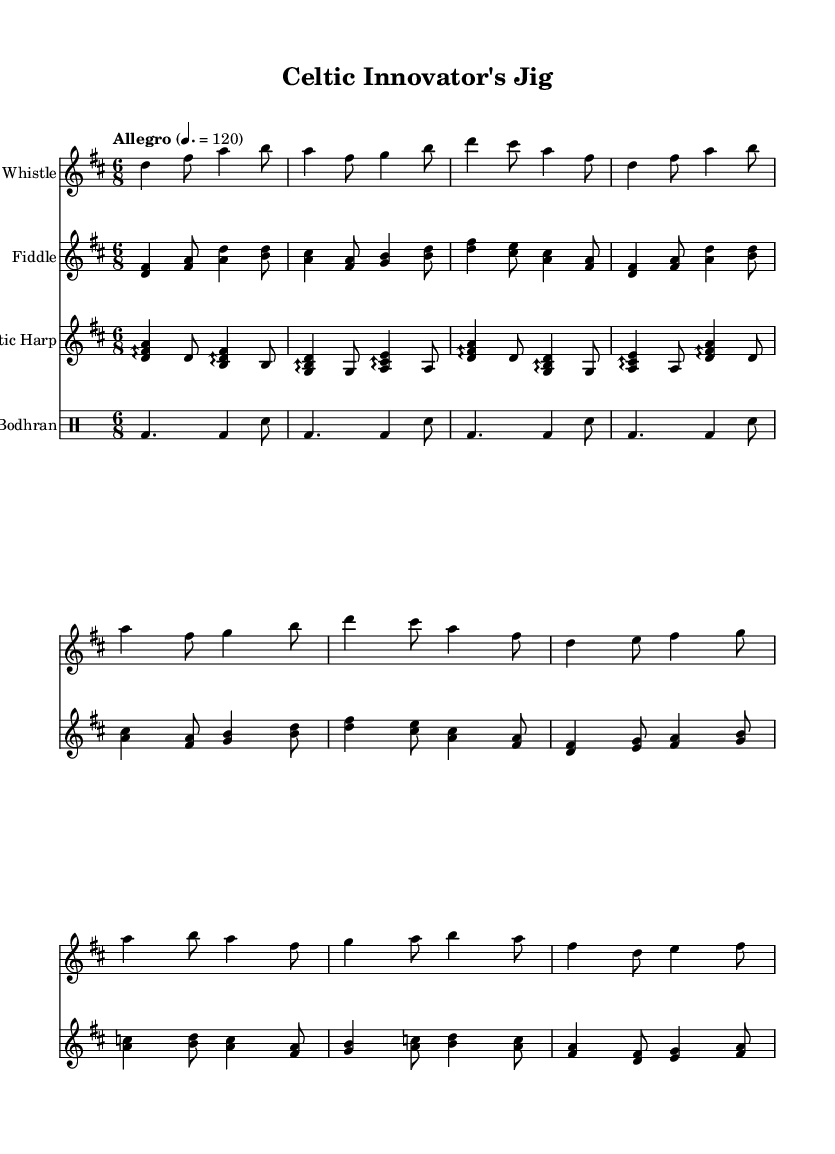What is the key signature of this music? The key signature is shown at the beginning of the staff, and it indicates D major. D major has two sharps: F# and C#.
Answer: D major What is the time signature of this music? The time signature appears right after the key signature and is indicated as 6/8. This means there are 6 eighth notes per measure.
Answer: 6/8 What is the tempo marking for this piece? The tempo marking is located near the top of the score and indicates how fast the piece should be played. It states "Allegro," and the number 120 indicates the beats per minute.
Answer: Allegro 120 How many instruments are used in this score? By looking at the score, each line indicates a different instrument. There are four distinct instruments: Tin Whistle, Fiddle, Celtic Harp, and Bodhran.
Answer: Four What type of musical form does this piece likely represent? The repeated melodic phrases often found in traditional folk music suggest a binary or repeated structure typically used in jigs. This can be observed in the stanza-like annotations of the music.
Answer: Jig What is the primary rhythmic feel of this piece? The piece is set in 6/8 time with a lively tempo, resulting in a flowing and dance-like feel, which is characteristic of many Celtic folk styles. This rhythmic arrangement emphasizes a triplet feel.
Answer: Lively What does the arpeggio notation indicate for the harp? The arpeggio notation suggests that the harpist should play the notes of the chords in sequence rather than simultaneously, creating a flowing sound. This technique is common in Celtic harp music and adds to the texture.
Answer: Arpeggiated chords 